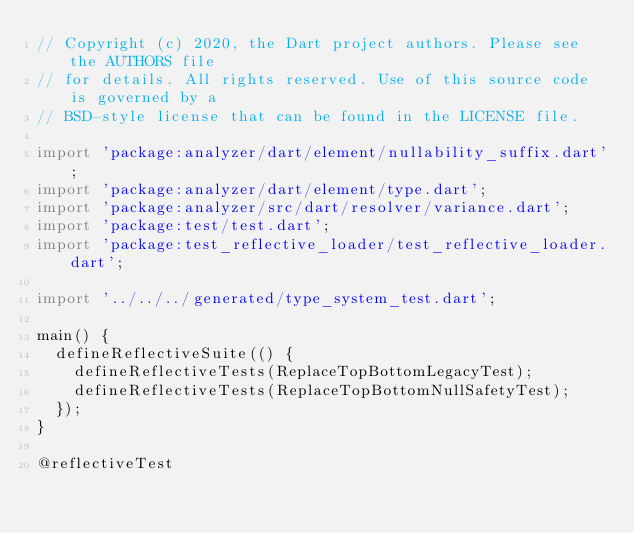<code> <loc_0><loc_0><loc_500><loc_500><_Dart_>// Copyright (c) 2020, the Dart project authors. Please see the AUTHORS file
// for details. All rights reserved. Use of this source code is governed by a
// BSD-style license that can be found in the LICENSE file.

import 'package:analyzer/dart/element/nullability_suffix.dart';
import 'package:analyzer/dart/element/type.dart';
import 'package:analyzer/src/dart/resolver/variance.dart';
import 'package:test/test.dart';
import 'package:test_reflective_loader/test_reflective_loader.dart';

import '../../../generated/type_system_test.dart';

main() {
  defineReflectiveSuite(() {
    defineReflectiveTests(ReplaceTopBottomLegacyTest);
    defineReflectiveTests(ReplaceTopBottomNullSafetyTest);
  });
}

@reflectiveTest</code> 